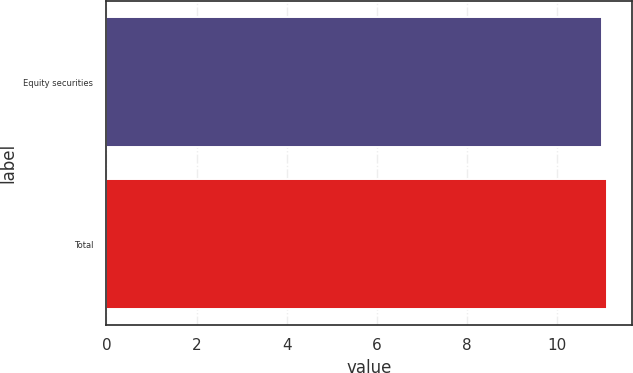Convert chart to OTSL. <chart><loc_0><loc_0><loc_500><loc_500><bar_chart><fcel>Equity securities<fcel>Total<nl><fcel>11<fcel>11.1<nl></chart> 